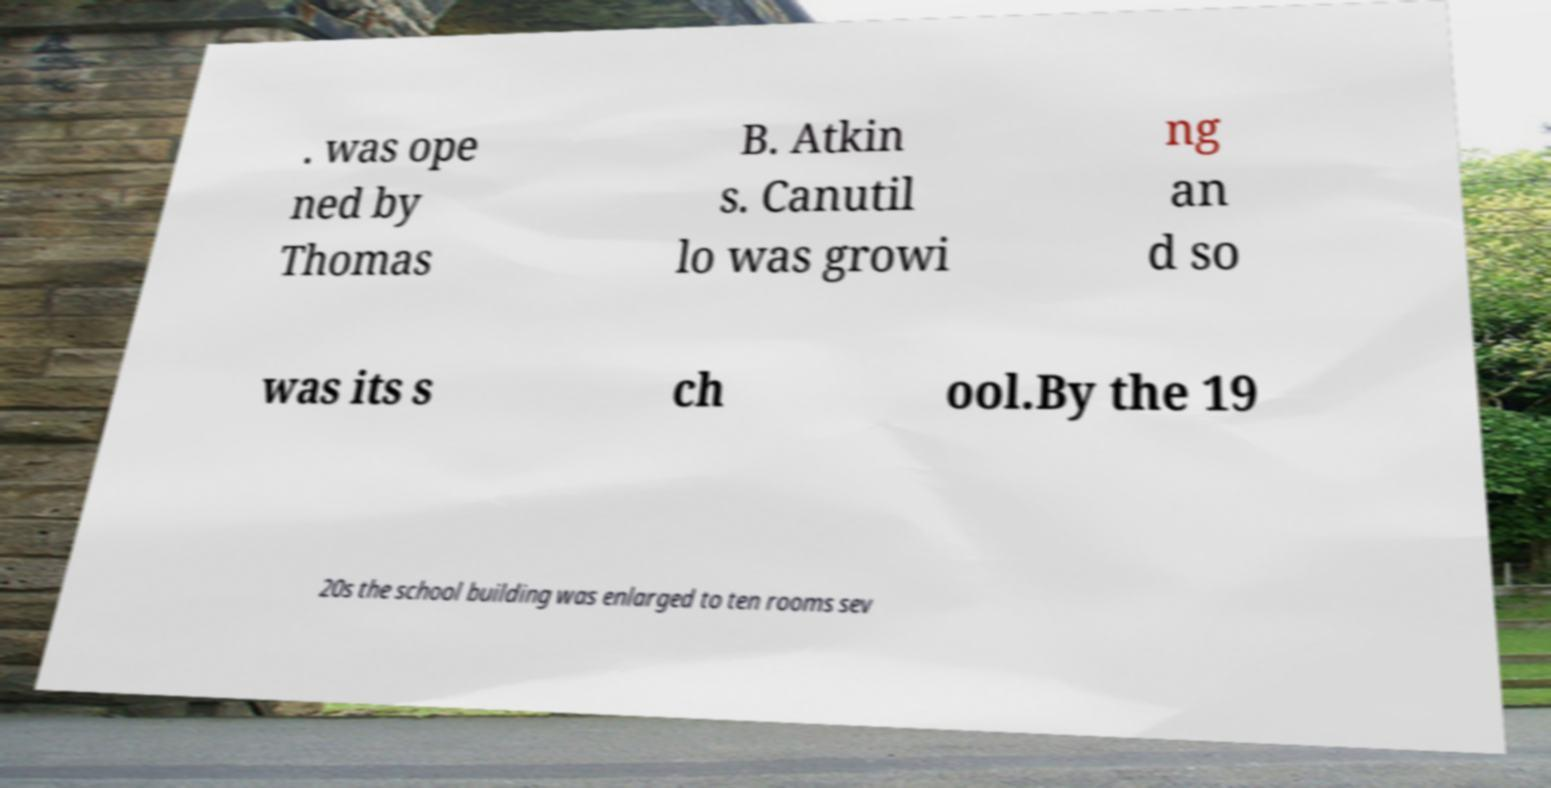I need the written content from this picture converted into text. Can you do that? . was ope ned by Thomas B. Atkin s. Canutil lo was growi ng an d so was its s ch ool.By the 19 20s the school building was enlarged to ten rooms sev 